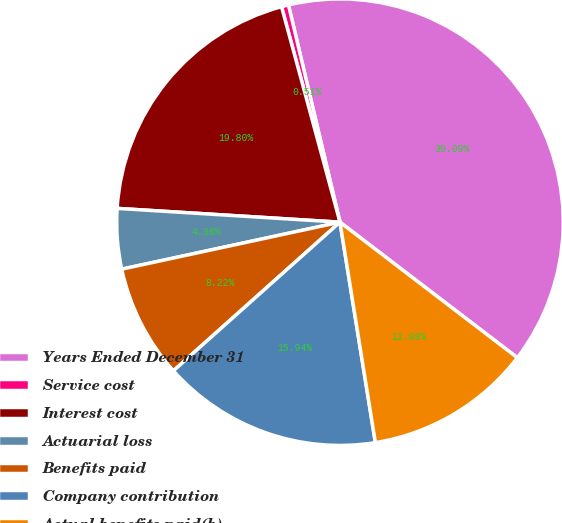Convert chart. <chart><loc_0><loc_0><loc_500><loc_500><pie_chart><fcel>Years Ended December 31<fcel>Service cost<fcel>Interest cost<fcel>Actuarial loss<fcel>Benefits paid<fcel>Company contribution<fcel>Actual benefits paid(b)<nl><fcel>39.09%<fcel>0.51%<fcel>19.8%<fcel>4.36%<fcel>8.22%<fcel>15.94%<fcel>12.08%<nl></chart> 